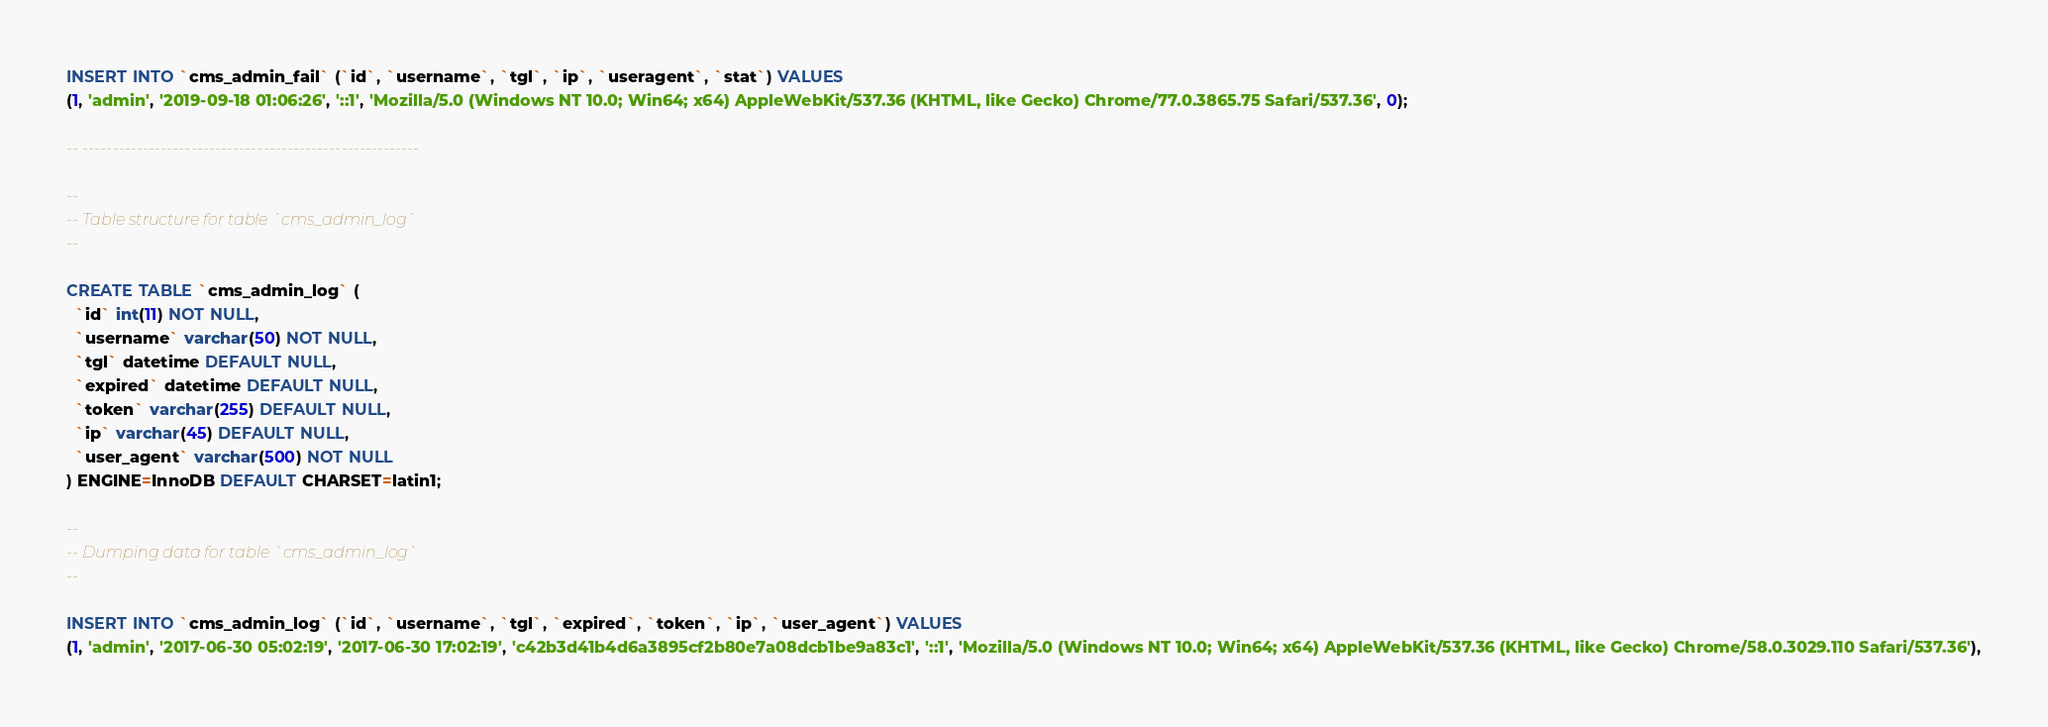Convert code to text. <code><loc_0><loc_0><loc_500><loc_500><_SQL_>INSERT INTO `cms_admin_fail` (`id`, `username`, `tgl`, `ip`, `useragent`, `stat`) VALUES
(1, 'admin', '2019-09-18 01:06:26', '::1', 'Mozilla/5.0 (Windows NT 10.0; Win64; x64) AppleWebKit/537.36 (KHTML, like Gecko) Chrome/77.0.3865.75 Safari/537.36', 0);

-- --------------------------------------------------------

--
-- Table structure for table `cms_admin_log`
--

CREATE TABLE `cms_admin_log` (
  `id` int(11) NOT NULL,
  `username` varchar(50) NOT NULL,
  `tgl` datetime DEFAULT NULL,
  `expired` datetime DEFAULT NULL,
  `token` varchar(255) DEFAULT NULL,
  `ip` varchar(45) DEFAULT NULL,
  `user_agent` varchar(500) NOT NULL
) ENGINE=InnoDB DEFAULT CHARSET=latin1;

--
-- Dumping data for table `cms_admin_log`
--

INSERT INTO `cms_admin_log` (`id`, `username`, `tgl`, `expired`, `token`, `ip`, `user_agent`) VALUES
(1, 'admin', '2017-06-30 05:02:19', '2017-06-30 17:02:19', 'c42b3d41b4d6a3895cf2b80e7a08dcb1be9a83c1', '::1', 'Mozilla/5.0 (Windows NT 10.0; Win64; x64) AppleWebKit/537.36 (KHTML, like Gecko) Chrome/58.0.3029.110 Safari/537.36'),</code> 